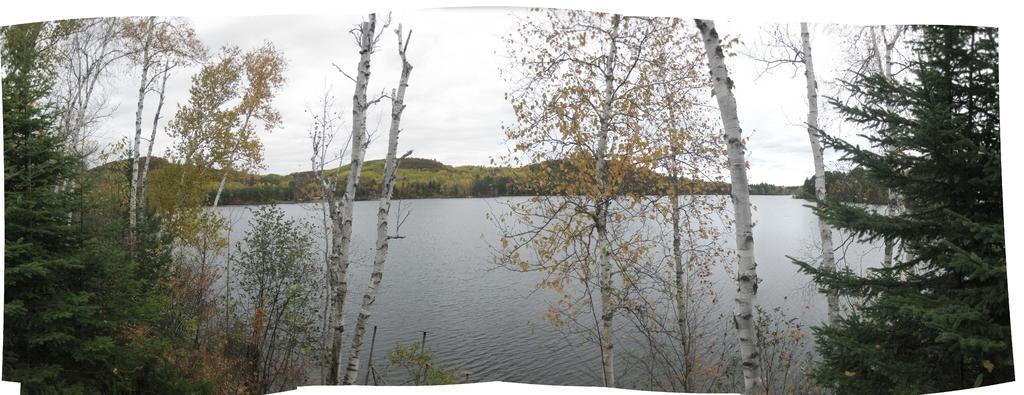In one or two sentences, can you explain what this image depicts? Here in this picture we can see a river as we can see water present all over there and we can also see plants and trees in the front and in the far we can see mountains that are covered with grass and plants over there and we can see clouds in the sky over there. 